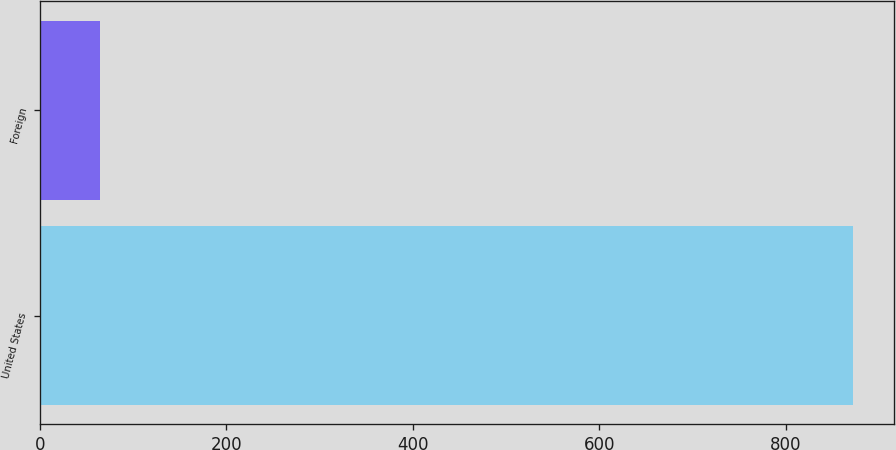Convert chart. <chart><loc_0><loc_0><loc_500><loc_500><bar_chart><fcel>United States<fcel>Foreign<nl><fcel>872.1<fcel>64.3<nl></chart> 